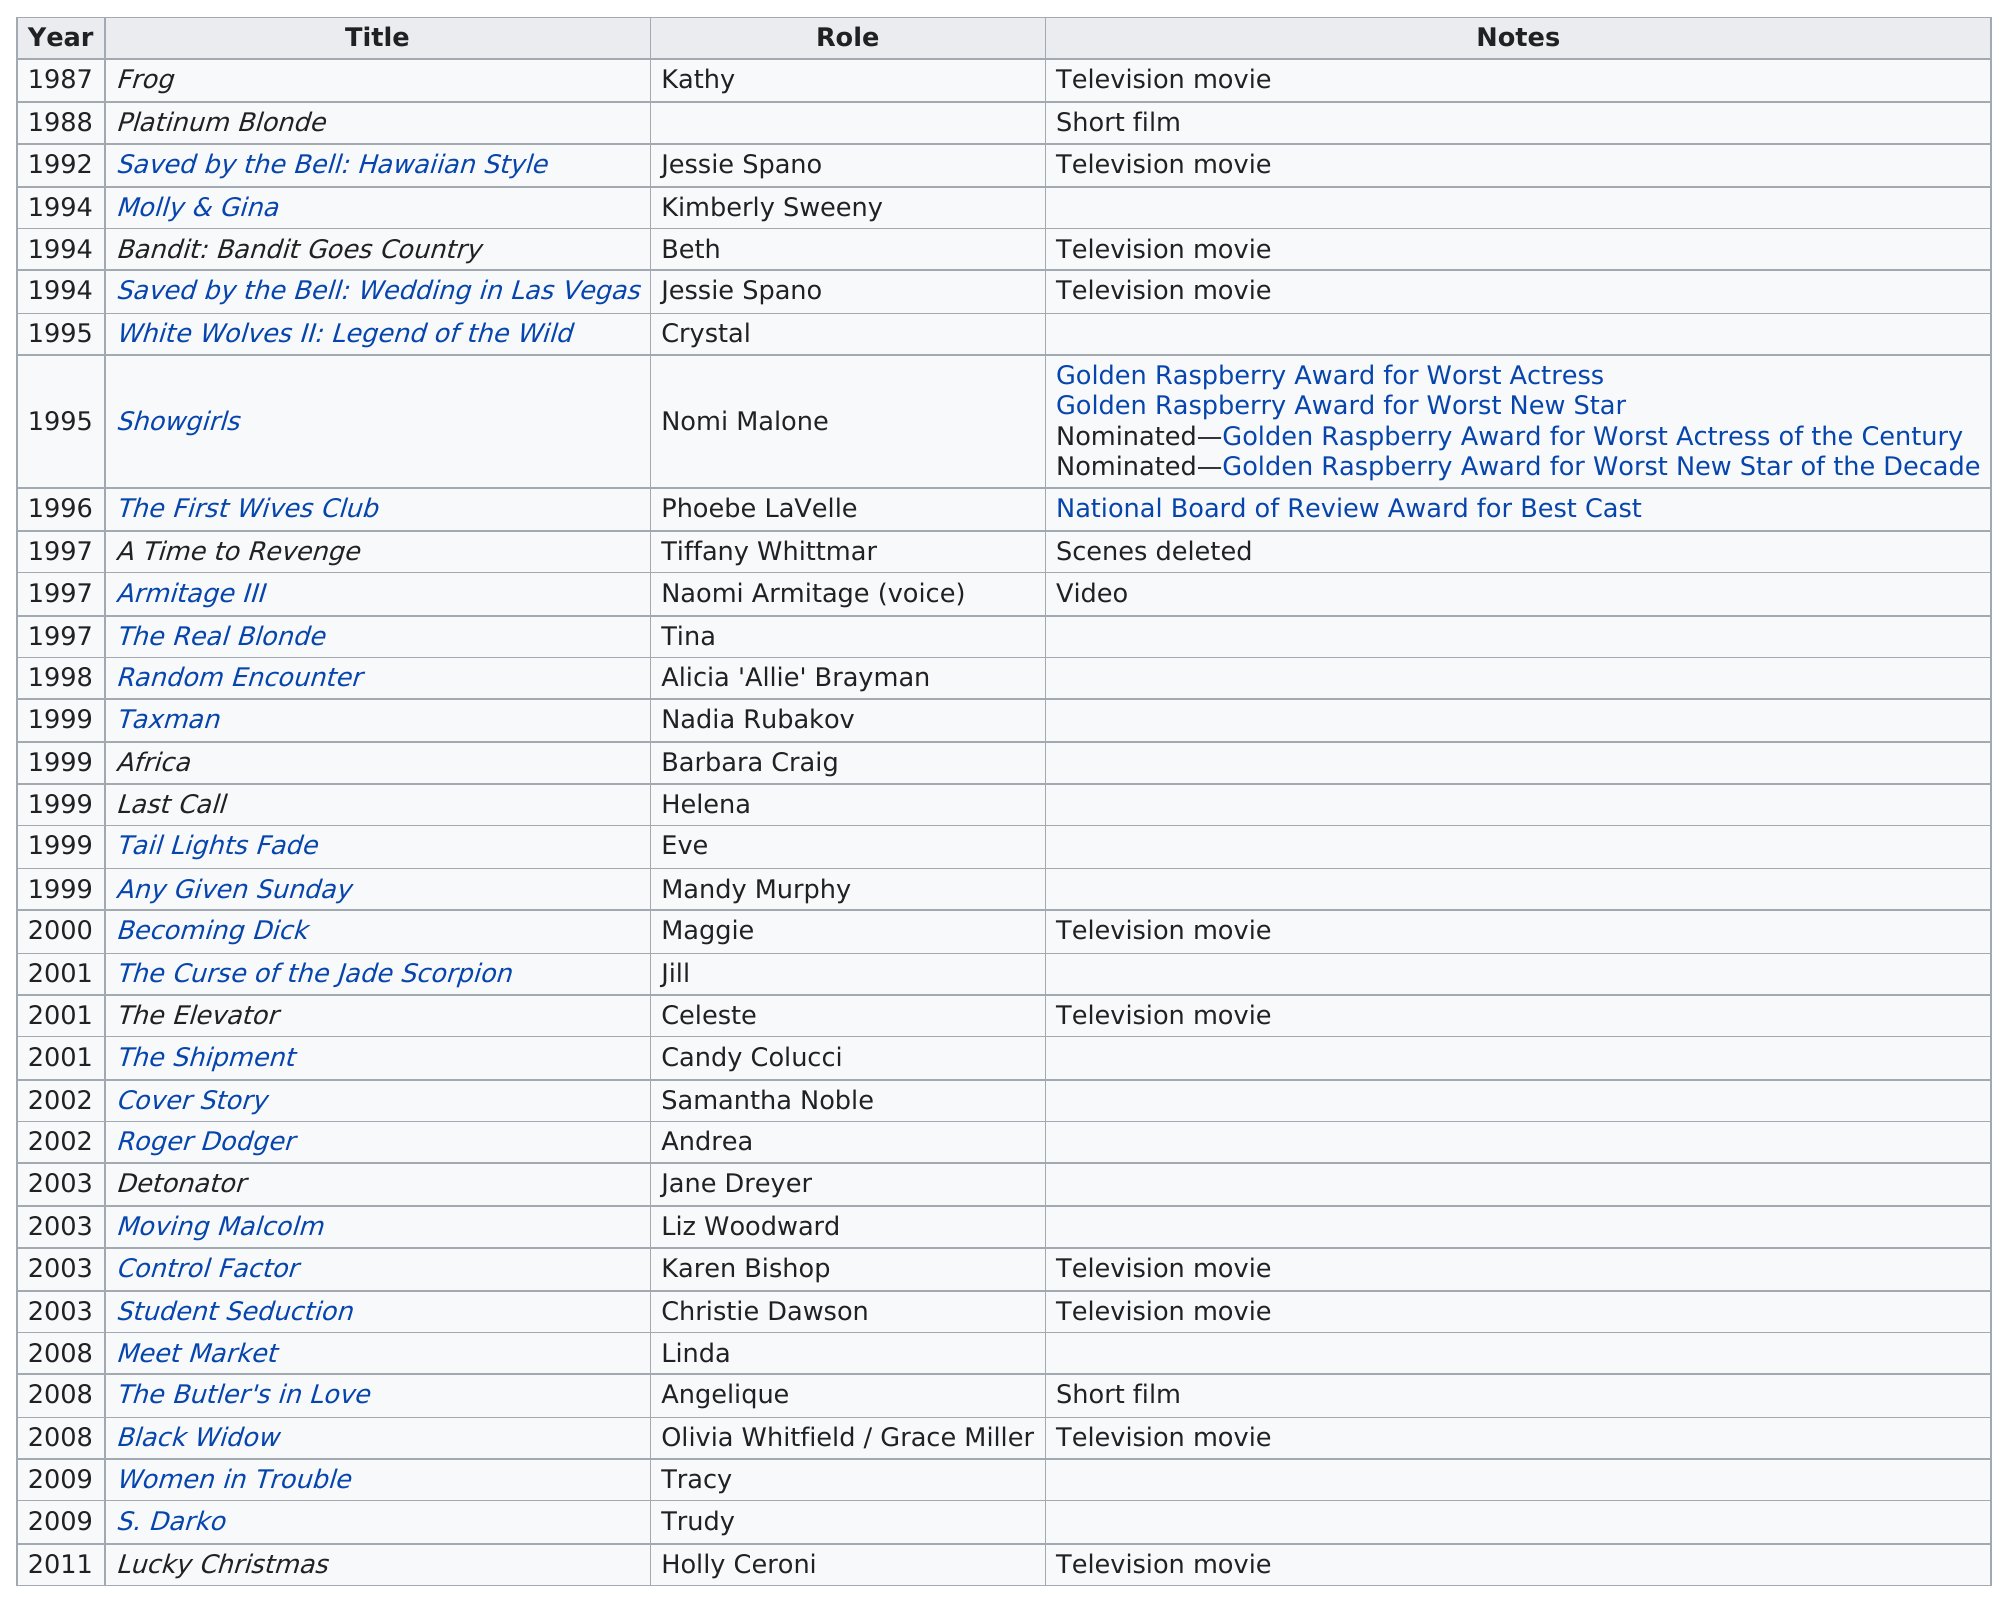Outline some significant characteristics in this image. Elizabeth Berkley's film "Showgirls" received the most award nominations out of all her films. Out of the films listed, 10 were television movies. Any Given Sunday, a film released in the year 1999, starred Mandy Murphy in a role. 